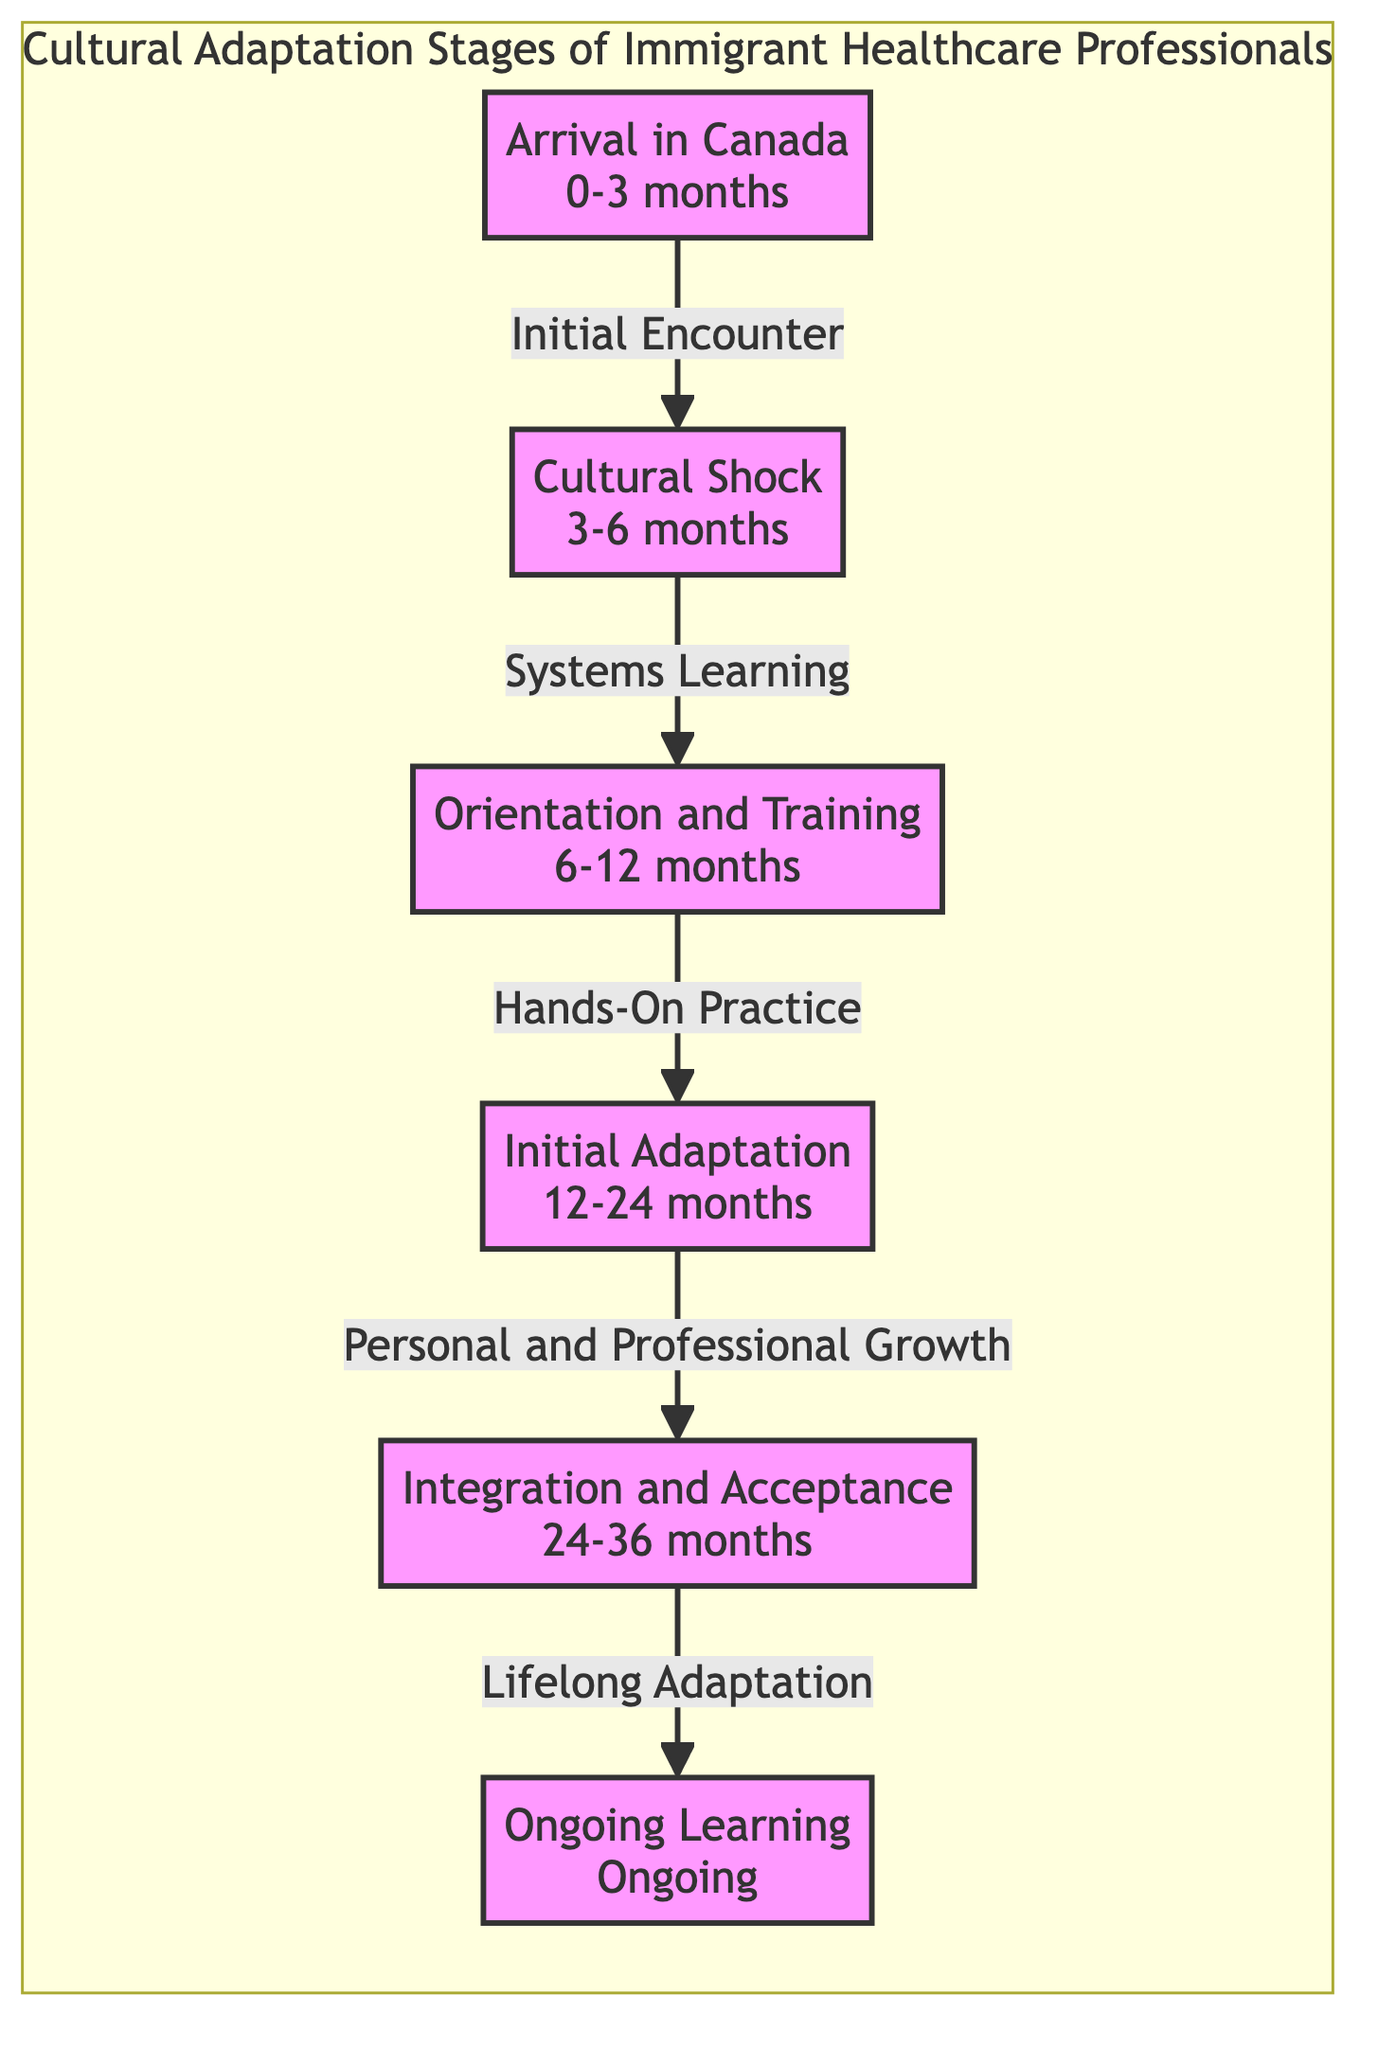What is the first stage in the adaptation process? The diagram begins with the first node labeled "Arrival in Canada," which represents the initial stage of the adaptation process.
Answer: Arrival in Canada How many stages are represented in the diagram? The diagram contains a total of six distinct stages of cultural adaptation for immigrant healthcare professionals.
Answer: 6 What milestone follows "Cultural Shock"? The next node after "Cultural Shock" is labeled "Orientation and Training," indicating what comes after the initial culture shock period.
Answer: Orientation and Training What is the time range for the "Initial Adaptation" stage? The information in the "Initial Adaptation" node specifies the time frame of "12-24 months" for this stage of adaptation.
Answer: 12-24 months What does the edge from "Integration and Acceptance" lead to? Following the edge from "Integration and Acceptance," the arrow points to the node "Ongoing Learning," indicating that this is the next stage in the progression.
Answer: Ongoing Learning Which stage is associated with "Personal and Professional Growth"? The label "Personal and Professional Growth" is associated with the "Initial Adaptation" stage, as indicated on the connecting edge in the diagram.
Answer: Initial Adaptation What is the relationship between "Orientation and Training" and "Cultural Shock"? "Orientation and Training" is the stage following "Cultural Shock," as shown by the arrow that connects these two stages in the diagram.
Answer: Systems Learning What color represents the "Ongoing Learning" stage? The color associated with the node "Ongoing Learning" is indicated as a light lavender, specifically the hex values provided in the diagram.
Answer: Light lavender What does the edge labeled "Hands-On Practice" indicate? The "Hands-On Practice" label describes the connection between "Orientation and Training" and "Initial Adaptation," showing that practical experience follows orientation.
Answer: Initial Adaptation 